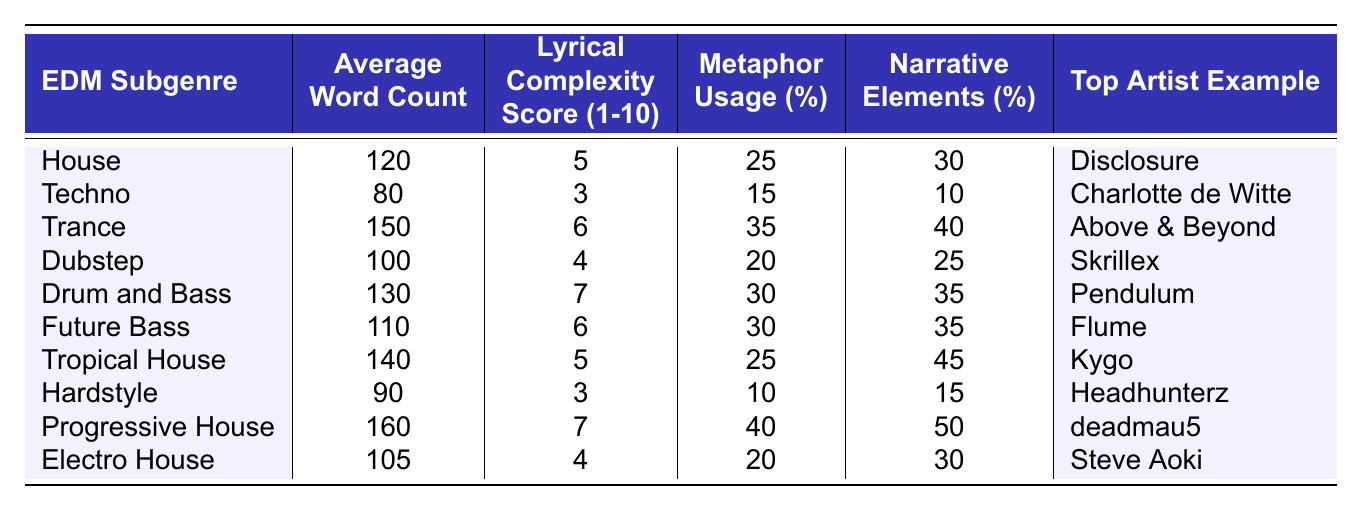What is the average word count for the Tropical House subgenre? Referring to the table, the Tropical House subgenre has an Average Word Count entry of 140.
Answer: 140 Which EDM subgenre has the highest lyrical complexity score? The table shows that both Drum and Bass and Progressive House have the highest Lyrical Complexity Score of 7.
Answer: Drum and Bass and Progressive House What percentage of metaphors is used in Dubstep? In the table, the Dubstep subgenre has a Metaphor Usage percentage of 20%.
Answer: 20% Which EDM subgenre has the lowest narrative elements percentage? The Techno subgenre has the lowest Narrative Elements percentage, which is 10%, as seen in the table.
Answer: 10% Calculate the average lyrical complexity score across all electronic dance music subgenres. The scores are 5, 3, 6, 4, 7, 6, 5, 3, 7, and 4. Adding them gives 50, and dividing by 10 (total subgenres) gives an average of 5.
Answer: 5 Is there a subgenre with both high lyrical complexity and metaphor usage? Checking the table, Drum and Bass (Lyrical Complexity Score 7, Metaphor Usage 30%) and Progressive House (Lyrical Complexity Score 7, Metaphor Usage 40%) meet this criterion.
Answer: Yes What is the difference in average word count between Trance and Hardstyle? The Average Word Count for Trance is 150 and for Hardstyle is 90. The difference is 150 - 90 = 60.
Answer: 60 Which subgenre uses the highest percentage of narrative elements? The table indicates that Progressive House has the highest Narrative Elements percentage at 50%.
Answer: 50% Does Future Bass have a higher lyrical complexity score than House? According to the table, Future Bass has a Lyrical Complexity Score of 6, while House has a score of 5, indicating True.
Answer: Yes What is the total metaphor usage percentage for House and Tropical House combined? The Metaphor Usage for House is 25%, and for Tropical House, it is also 25%. Adding them gives 25 + 25 = 50%.
Answer: 50% 